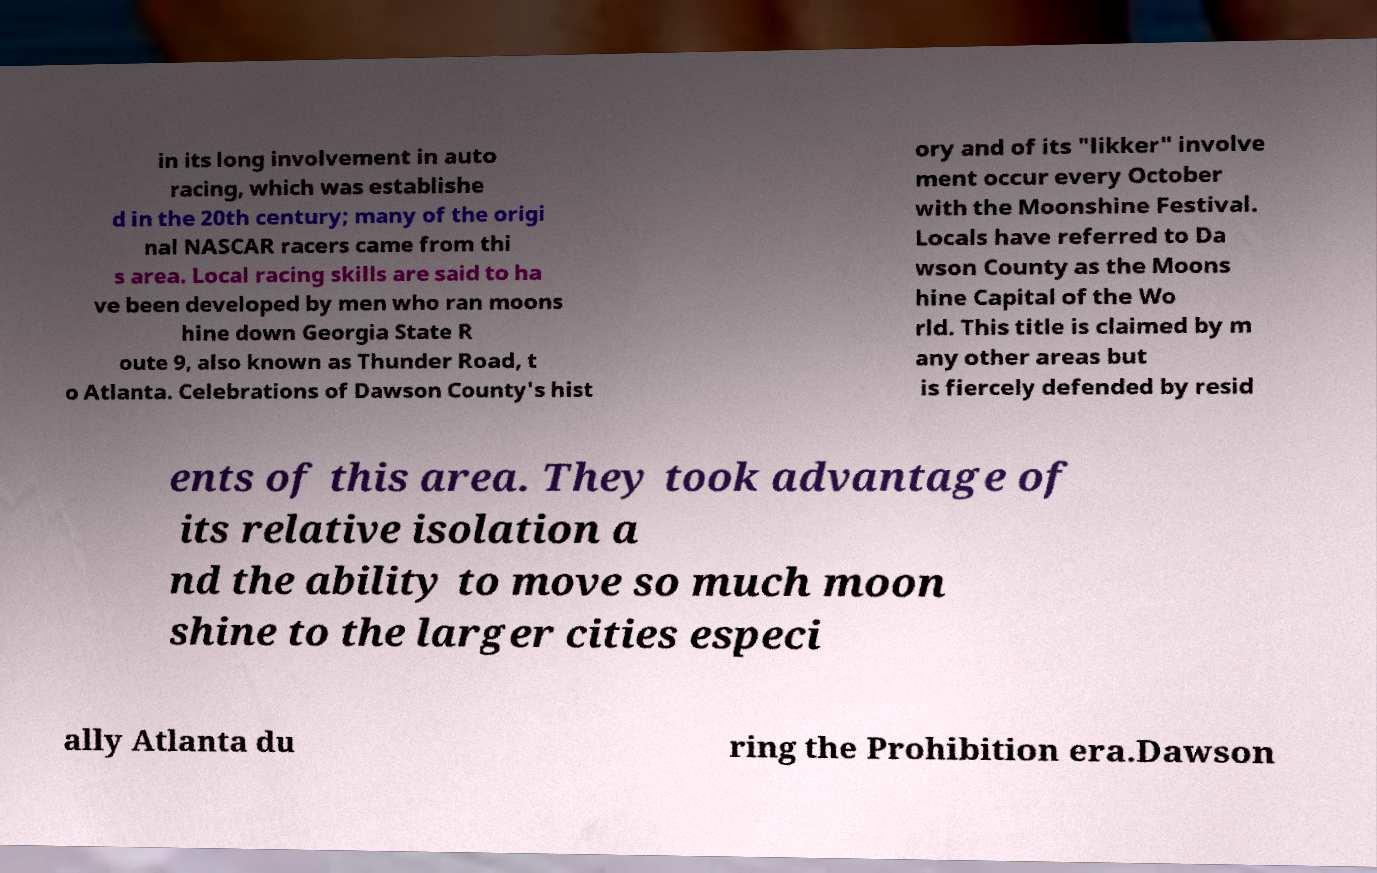Can you read and provide the text displayed in the image?This photo seems to have some interesting text. Can you extract and type it out for me? in its long involvement in auto racing, which was establishe d in the 20th century; many of the origi nal NASCAR racers came from thi s area. Local racing skills are said to ha ve been developed by men who ran moons hine down Georgia State R oute 9, also known as Thunder Road, t o Atlanta. Celebrations of Dawson County's hist ory and of its "likker" involve ment occur every October with the Moonshine Festival. Locals have referred to Da wson County as the Moons hine Capital of the Wo rld. This title is claimed by m any other areas but is fiercely defended by resid ents of this area. They took advantage of its relative isolation a nd the ability to move so much moon shine to the larger cities especi ally Atlanta du ring the Prohibition era.Dawson 